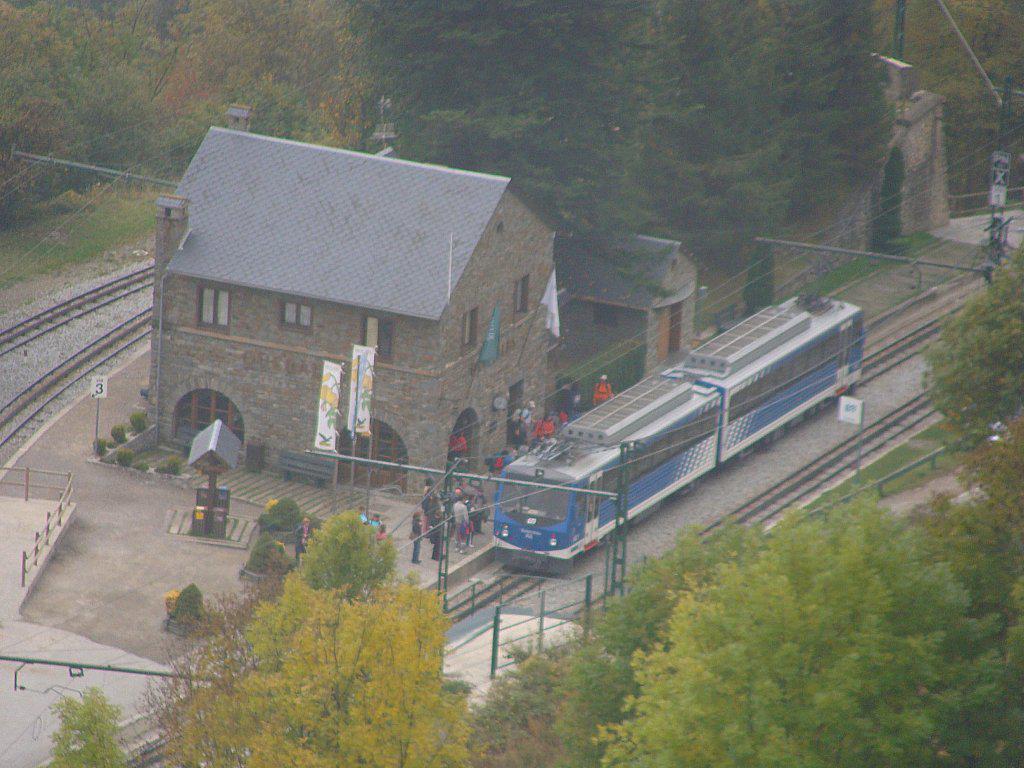Describe this image in one or two sentences. This is an aerial view of an image where we can see trees, a train moving on the railway track, people standing on the road, I can see boards, poles, houses, wires and a few more railway tracks. 